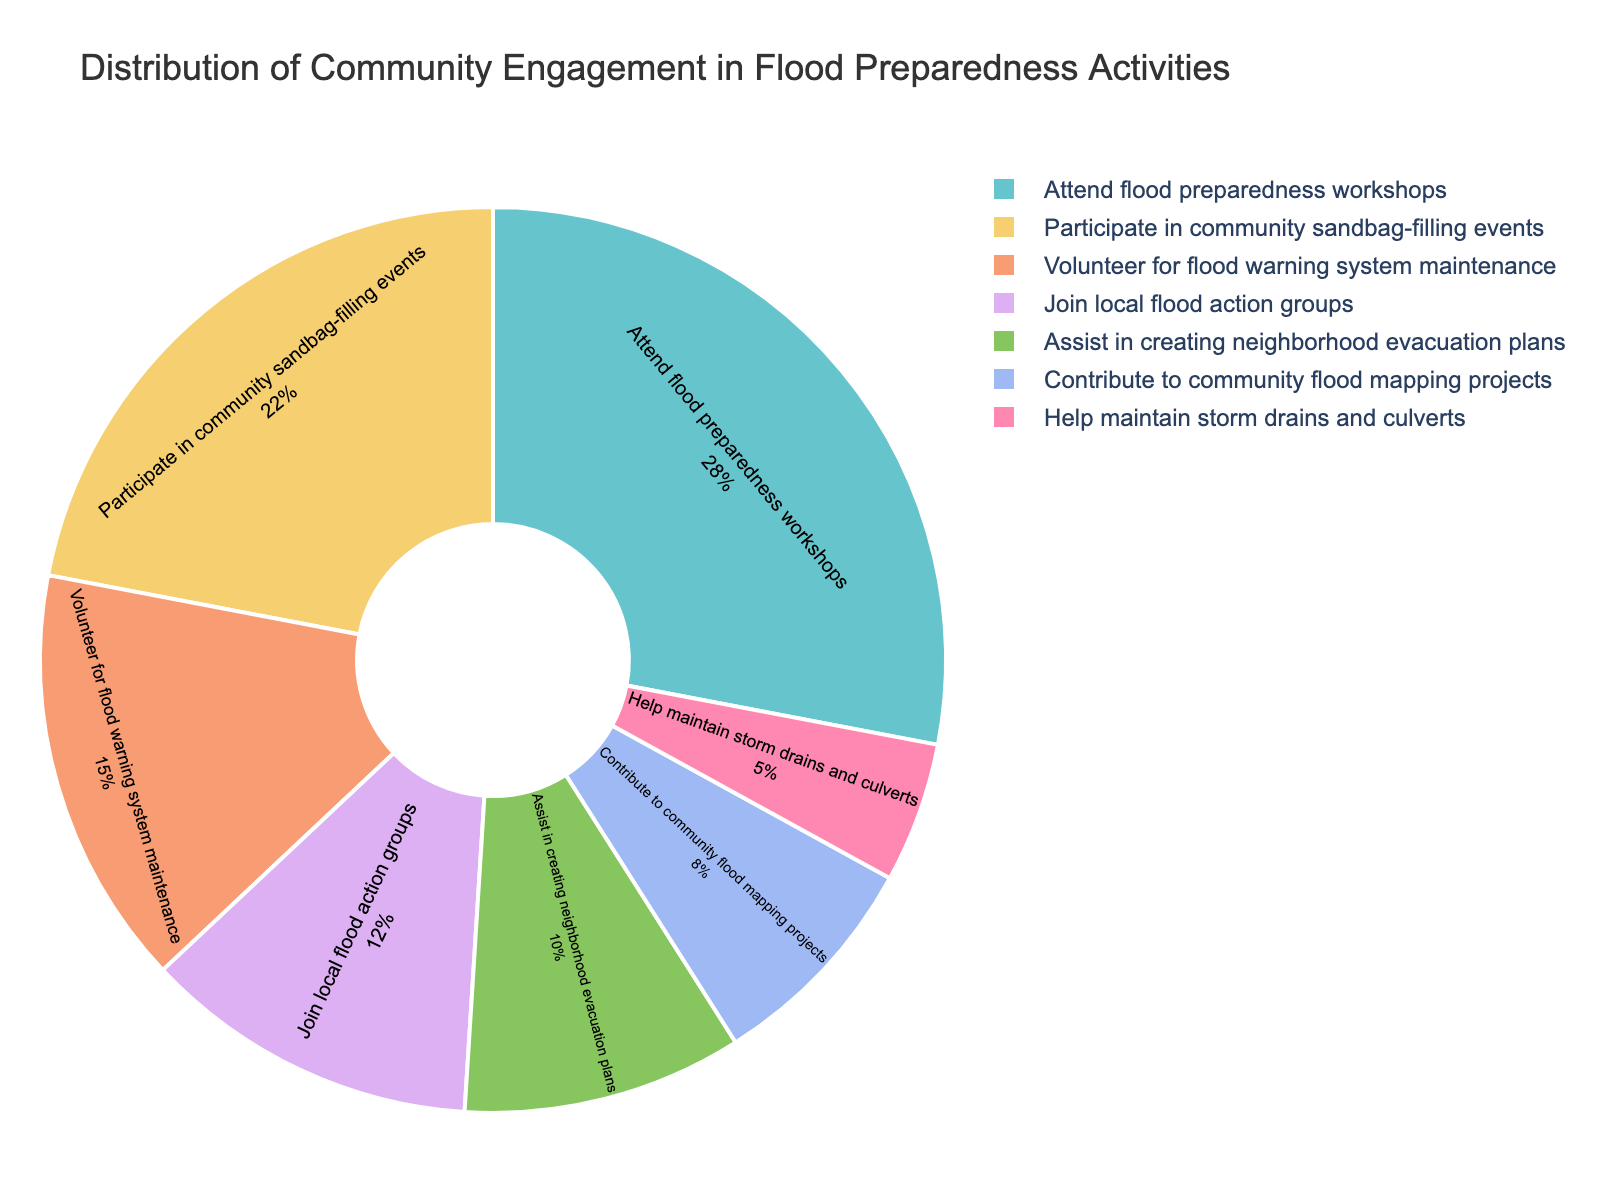What's the most popular flood preparedness activity in the community? Look for the activity with the highest percentage in the chart. "Attend flood preparedness workshops" has the highest percentage at 28%.
Answer: Attend flood preparedness workshops What is the difference in engagement between attending workshops and participating in sandbag-filling events? Compare the percentages for "Attend flood preparedness workshops" (28%) and "Participate in community sandbag-filling events" (22%). The difference is 28% - 22% = 6%.
Answer: 6% How does the community’s engagement in assisting evacuation plans compare to maintaining storm drains and culverts? Compare the percentages for "Assist in creating neighborhood evacuation plans" (10%) and "Help maintain storm drains and culverts" (5%). Engagement in assisting evacuation plans is 10% while maintaining storm drains is 5%, so 10% is greater than 5%.
Answer: Assisting evacuation plans is greater What percentage of the community is involved in flood warning system maintenance and flood action groups combined? Add the percentages of "Volunteer for flood warning system maintenance" (15%) and "Join local flood action groups" (12%). The combined engagement is 15% + 12% = 27%.
Answer: 27% Is participation in sandbag-filling events greater than or less than contributing to flood mapping projects? Compare the percentages for "Participate in community sandbag-filling events" (22%) and "Contribute to community flood mapping projects" (8%). Participation in sandbag-filling events (22%) is greater than contributing to flood mapping projects (8%).
Answer: Greater What is the average percentage of engagement in the top three activities? The top three activities by percentage are "Attend flood preparedness workshops" (28%), "Participate in community sandbag-filling events" (22%), and "Volunteer for flood warning system maintenance" (15%). The average is (28 + 22 + 15) / 3 = 65 / 3 ≈ 21.67%.
Answer: 21.67% Does the sum of percentages for storm drain maintenance, sandbag-filling, and flood action groups exceed 40%? Add the percentages for "Help maintain storm drains and culverts" (5%), "Participate in community sandbag-filling events" (22%), and "Join local flood action groups" (12%). The sum is 5% + 22% + 12% = 39%, which does not exceed 40%.
Answer: No Which flood preparedness activity has the lowest engagement? Look for the activity with the smallest percentage in the chart. "Help maintain storm drains and culverts" has the lowest engagement at 5%.
Answer: Help maintain storm drains and culverts 